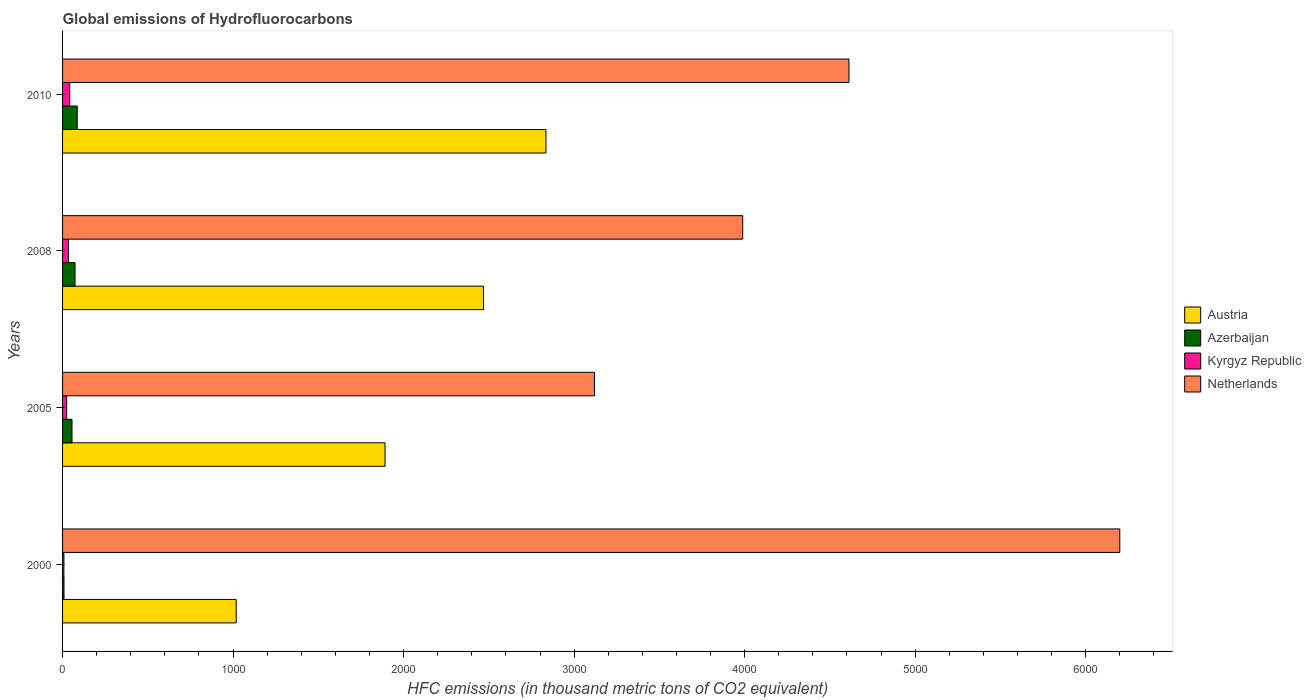How many groups of bars are there?
Your answer should be very brief. 4. Are the number of bars on each tick of the Y-axis equal?
Provide a short and direct response. Yes. How many bars are there on the 4th tick from the bottom?
Provide a succinct answer. 4. What is the global emissions of Hydrofluorocarbons in Austria in 2005?
Offer a very short reply. 1891.2. Across all years, what is the minimum global emissions of Hydrofluorocarbons in Azerbaijan?
Your answer should be very brief. 8.5. What is the total global emissions of Hydrofluorocarbons in Kyrgyz Republic in the graph?
Offer a terse response. 108.7. What is the difference between the global emissions of Hydrofluorocarbons in Austria in 2008 and that in 2010?
Ensure brevity in your answer.  -366.1. What is the difference between the global emissions of Hydrofluorocarbons in Kyrgyz Republic in 2010 and the global emissions of Hydrofluorocarbons in Netherlands in 2005?
Keep it short and to the point. -3077.5. What is the average global emissions of Hydrofluorocarbons in Austria per year?
Provide a short and direct response. 2053.38. In the year 2005, what is the difference between the global emissions of Hydrofluorocarbons in Netherlands and global emissions of Hydrofluorocarbons in Austria?
Give a very brief answer. 1228.3. What is the ratio of the global emissions of Hydrofluorocarbons in Kyrgyz Republic in 2000 to that in 2010?
Your answer should be compact. 0.19. Is the global emissions of Hydrofluorocarbons in Austria in 2000 less than that in 2010?
Provide a short and direct response. Yes. What is the difference between the highest and the second highest global emissions of Hydrofluorocarbons in Azerbaijan?
Offer a terse response. 12.9. What is the difference between the highest and the lowest global emissions of Hydrofluorocarbons in Austria?
Offer a terse response. 1816.6. Is the sum of the global emissions of Hydrofluorocarbons in Kyrgyz Republic in 2000 and 2005 greater than the maximum global emissions of Hydrofluorocarbons in Azerbaijan across all years?
Make the answer very short. No. What does the 2nd bar from the top in 2005 represents?
Your response must be concise. Kyrgyz Republic. What does the 2nd bar from the bottom in 2008 represents?
Your answer should be very brief. Azerbaijan. How many bars are there?
Your response must be concise. 16. Are all the bars in the graph horizontal?
Your answer should be compact. Yes. Are the values on the major ticks of X-axis written in scientific E-notation?
Your response must be concise. No. What is the title of the graph?
Your answer should be very brief. Global emissions of Hydrofluorocarbons. What is the label or title of the X-axis?
Provide a succinct answer. HFC emissions (in thousand metric tons of CO2 equivalent). What is the HFC emissions (in thousand metric tons of CO2 equivalent) of Austria in 2000?
Your answer should be compact. 1018.4. What is the HFC emissions (in thousand metric tons of CO2 equivalent) in Azerbaijan in 2000?
Offer a terse response. 8.5. What is the HFC emissions (in thousand metric tons of CO2 equivalent) of Netherlands in 2000?
Offer a terse response. 6200.4. What is the HFC emissions (in thousand metric tons of CO2 equivalent) in Austria in 2005?
Your response must be concise. 1891.2. What is the HFC emissions (in thousand metric tons of CO2 equivalent) in Azerbaijan in 2005?
Give a very brief answer. 55.4. What is the HFC emissions (in thousand metric tons of CO2 equivalent) of Netherlands in 2005?
Give a very brief answer. 3119.5. What is the HFC emissions (in thousand metric tons of CO2 equivalent) in Austria in 2008?
Offer a very short reply. 2468.9. What is the HFC emissions (in thousand metric tons of CO2 equivalent) of Azerbaijan in 2008?
Offer a terse response. 73.1. What is the HFC emissions (in thousand metric tons of CO2 equivalent) in Kyrgyz Republic in 2008?
Provide a short and direct response. 34.8. What is the HFC emissions (in thousand metric tons of CO2 equivalent) of Netherlands in 2008?
Give a very brief answer. 3988.8. What is the HFC emissions (in thousand metric tons of CO2 equivalent) in Austria in 2010?
Make the answer very short. 2835. What is the HFC emissions (in thousand metric tons of CO2 equivalent) in Kyrgyz Republic in 2010?
Offer a very short reply. 42. What is the HFC emissions (in thousand metric tons of CO2 equivalent) in Netherlands in 2010?
Keep it short and to the point. 4612. Across all years, what is the maximum HFC emissions (in thousand metric tons of CO2 equivalent) in Austria?
Offer a terse response. 2835. Across all years, what is the maximum HFC emissions (in thousand metric tons of CO2 equivalent) of Azerbaijan?
Give a very brief answer. 86. Across all years, what is the maximum HFC emissions (in thousand metric tons of CO2 equivalent) in Netherlands?
Give a very brief answer. 6200.4. Across all years, what is the minimum HFC emissions (in thousand metric tons of CO2 equivalent) in Austria?
Give a very brief answer. 1018.4. Across all years, what is the minimum HFC emissions (in thousand metric tons of CO2 equivalent) in Azerbaijan?
Give a very brief answer. 8.5. Across all years, what is the minimum HFC emissions (in thousand metric tons of CO2 equivalent) in Kyrgyz Republic?
Make the answer very short. 7.9. Across all years, what is the minimum HFC emissions (in thousand metric tons of CO2 equivalent) in Netherlands?
Offer a very short reply. 3119.5. What is the total HFC emissions (in thousand metric tons of CO2 equivalent) in Austria in the graph?
Provide a short and direct response. 8213.5. What is the total HFC emissions (in thousand metric tons of CO2 equivalent) in Azerbaijan in the graph?
Provide a succinct answer. 223. What is the total HFC emissions (in thousand metric tons of CO2 equivalent) in Kyrgyz Republic in the graph?
Offer a terse response. 108.7. What is the total HFC emissions (in thousand metric tons of CO2 equivalent) in Netherlands in the graph?
Your response must be concise. 1.79e+04. What is the difference between the HFC emissions (in thousand metric tons of CO2 equivalent) in Austria in 2000 and that in 2005?
Offer a very short reply. -872.8. What is the difference between the HFC emissions (in thousand metric tons of CO2 equivalent) of Azerbaijan in 2000 and that in 2005?
Offer a terse response. -46.9. What is the difference between the HFC emissions (in thousand metric tons of CO2 equivalent) of Kyrgyz Republic in 2000 and that in 2005?
Your answer should be very brief. -16.1. What is the difference between the HFC emissions (in thousand metric tons of CO2 equivalent) of Netherlands in 2000 and that in 2005?
Offer a terse response. 3080.9. What is the difference between the HFC emissions (in thousand metric tons of CO2 equivalent) in Austria in 2000 and that in 2008?
Provide a short and direct response. -1450.5. What is the difference between the HFC emissions (in thousand metric tons of CO2 equivalent) in Azerbaijan in 2000 and that in 2008?
Make the answer very short. -64.6. What is the difference between the HFC emissions (in thousand metric tons of CO2 equivalent) in Kyrgyz Republic in 2000 and that in 2008?
Make the answer very short. -26.9. What is the difference between the HFC emissions (in thousand metric tons of CO2 equivalent) in Netherlands in 2000 and that in 2008?
Offer a very short reply. 2211.6. What is the difference between the HFC emissions (in thousand metric tons of CO2 equivalent) of Austria in 2000 and that in 2010?
Your answer should be compact. -1816.6. What is the difference between the HFC emissions (in thousand metric tons of CO2 equivalent) of Azerbaijan in 2000 and that in 2010?
Provide a succinct answer. -77.5. What is the difference between the HFC emissions (in thousand metric tons of CO2 equivalent) of Kyrgyz Republic in 2000 and that in 2010?
Offer a very short reply. -34.1. What is the difference between the HFC emissions (in thousand metric tons of CO2 equivalent) of Netherlands in 2000 and that in 2010?
Your response must be concise. 1588.4. What is the difference between the HFC emissions (in thousand metric tons of CO2 equivalent) in Austria in 2005 and that in 2008?
Your response must be concise. -577.7. What is the difference between the HFC emissions (in thousand metric tons of CO2 equivalent) in Azerbaijan in 2005 and that in 2008?
Your answer should be compact. -17.7. What is the difference between the HFC emissions (in thousand metric tons of CO2 equivalent) in Netherlands in 2005 and that in 2008?
Provide a succinct answer. -869.3. What is the difference between the HFC emissions (in thousand metric tons of CO2 equivalent) in Austria in 2005 and that in 2010?
Offer a terse response. -943.8. What is the difference between the HFC emissions (in thousand metric tons of CO2 equivalent) in Azerbaijan in 2005 and that in 2010?
Your answer should be very brief. -30.6. What is the difference between the HFC emissions (in thousand metric tons of CO2 equivalent) of Kyrgyz Republic in 2005 and that in 2010?
Keep it short and to the point. -18. What is the difference between the HFC emissions (in thousand metric tons of CO2 equivalent) in Netherlands in 2005 and that in 2010?
Your answer should be compact. -1492.5. What is the difference between the HFC emissions (in thousand metric tons of CO2 equivalent) in Austria in 2008 and that in 2010?
Your response must be concise. -366.1. What is the difference between the HFC emissions (in thousand metric tons of CO2 equivalent) in Netherlands in 2008 and that in 2010?
Give a very brief answer. -623.2. What is the difference between the HFC emissions (in thousand metric tons of CO2 equivalent) in Austria in 2000 and the HFC emissions (in thousand metric tons of CO2 equivalent) in Azerbaijan in 2005?
Give a very brief answer. 963. What is the difference between the HFC emissions (in thousand metric tons of CO2 equivalent) in Austria in 2000 and the HFC emissions (in thousand metric tons of CO2 equivalent) in Kyrgyz Republic in 2005?
Provide a succinct answer. 994.4. What is the difference between the HFC emissions (in thousand metric tons of CO2 equivalent) in Austria in 2000 and the HFC emissions (in thousand metric tons of CO2 equivalent) in Netherlands in 2005?
Offer a terse response. -2101.1. What is the difference between the HFC emissions (in thousand metric tons of CO2 equivalent) of Azerbaijan in 2000 and the HFC emissions (in thousand metric tons of CO2 equivalent) of Kyrgyz Republic in 2005?
Provide a succinct answer. -15.5. What is the difference between the HFC emissions (in thousand metric tons of CO2 equivalent) of Azerbaijan in 2000 and the HFC emissions (in thousand metric tons of CO2 equivalent) of Netherlands in 2005?
Offer a very short reply. -3111. What is the difference between the HFC emissions (in thousand metric tons of CO2 equivalent) in Kyrgyz Republic in 2000 and the HFC emissions (in thousand metric tons of CO2 equivalent) in Netherlands in 2005?
Your answer should be compact. -3111.6. What is the difference between the HFC emissions (in thousand metric tons of CO2 equivalent) of Austria in 2000 and the HFC emissions (in thousand metric tons of CO2 equivalent) of Azerbaijan in 2008?
Offer a very short reply. 945.3. What is the difference between the HFC emissions (in thousand metric tons of CO2 equivalent) in Austria in 2000 and the HFC emissions (in thousand metric tons of CO2 equivalent) in Kyrgyz Republic in 2008?
Provide a succinct answer. 983.6. What is the difference between the HFC emissions (in thousand metric tons of CO2 equivalent) of Austria in 2000 and the HFC emissions (in thousand metric tons of CO2 equivalent) of Netherlands in 2008?
Your response must be concise. -2970.4. What is the difference between the HFC emissions (in thousand metric tons of CO2 equivalent) of Azerbaijan in 2000 and the HFC emissions (in thousand metric tons of CO2 equivalent) of Kyrgyz Republic in 2008?
Make the answer very short. -26.3. What is the difference between the HFC emissions (in thousand metric tons of CO2 equivalent) of Azerbaijan in 2000 and the HFC emissions (in thousand metric tons of CO2 equivalent) of Netherlands in 2008?
Provide a short and direct response. -3980.3. What is the difference between the HFC emissions (in thousand metric tons of CO2 equivalent) in Kyrgyz Republic in 2000 and the HFC emissions (in thousand metric tons of CO2 equivalent) in Netherlands in 2008?
Your answer should be compact. -3980.9. What is the difference between the HFC emissions (in thousand metric tons of CO2 equivalent) in Austria in 2000 and the HFC emissions (in thousand metric tons of CO2 equivalent) in Azerbaijan in 2010?
Provide a succinct answer. 932.4. What is the difference between the HFC emissions (in thousand metric tons of CO2 equivalent) in Austria in 2000 and the HFC emissions (in thousand metric tons of CO2 equivalent) in Kyrgyz Republic in 2010?
Your answer should be compact. 976.4. What is the difference between the HFC emissions (in thousand metric tons of CO2 equivalent) of Austria in 2000 and the HFC emissions (in thousand metric tons of CO2 equivalent) of Netherlands in 2010?
Ensure brevity in your answer.  -3593.6. What is the difference between the HFC emissions (in thousand metric tons of CO2 equivalent) of Azerbaijan in 2000 and the HFC emissions (in thousand metric tons of CO2 equivalent) of Kyrgyz Republic in 2010?
Your response must be concise. -33.5. What is the difference between the HFC emissions (in thousand metric tons of CO2 equivalent) of Azerbaijan in 2000 and the HFC emissions (in thousand metric tons of CO2 equivalent) of Netherlands in 2010?
Ensure brevity in your answer.  -4603.5. What is the difference between the HFC emissions (in thousand metric tons of CO2 equivalent) of Kyrgyz Republic in 2000 and the HFC emissions (in thousand metric tons of CO2 equivalent) of Netherlands in 2010?
Your response must be concise. -4604.1. What is the difference between the HFC emissions (in thousand metric tons of CO2 equivalent) of Austria in 2005 and the HFC emissions (in thousand metric tons of CO2 equivalent) of Azerbaijan in 2008?
Provide a succinct answer. 1818.1. What is the difference between the HFC emissions (in thousand metric tons of CO2 equivalent) in Austria in 2005 and the HFC emissions (in thousand metric tons of CO2 equivalent) in Kyrgyz Republic in 2008?
Give a very brief answer. 1856.4. What is the difference between the HFC emissions (in thousand metric tons of CO2 equivalent) of Austria in 2005 and the HFC emissions (in thousand metric tons of CO2 equivalent) of Netherlands in 2008?
Offer a terse response. -2097.6. What is the difference between the HFC emissions (in thousand metric tons of CO2 equivalent) in Azerbaijan in 2005 and the HFC emissions (in thousand metric tons of CO2 equivalent) in Kyrgyz Republic in 2008?
Your answer should be very brief. 20.6. What is the difference between the HFC emissions (in thousand metric tons of CO2 equivalent) in Azerbaijan in 2005 and the HFC emissions (in thousand metric tons of CO2 equivalent) in Netherlands in 2008?
Make the answer very short. -3933.4. What is the difference between the HFC emissions (in thousand metric tons of CO2 equivalent) in Kyrgyz Republic in 2005 and the HFC emissions (in thousand metric tons of CO2 equivalent) in Netherlands in 2008?
Keep it short and to the point. -3964.8. What is the difference between the HFC emissions (in thousand metric tons of CO2 equivalent) of Austria in 2005 and the HFC emissions (in thousand metric tons of CO2 equivalent) of Azerbaijan in 2010?
Your answer should be very brief. 1805.2. What is the difference between the HFC emissions (in thousand metric tons of CO2 equivalent) of Austria in 2005 and the HFC emissions (in thousand metric tons of CO2 equivalent) of Kyrgyz Republic in 2010?
Your response must be concise. 1849.2. What is the difference between the HFC emissions (in thousand metric tons of CO2 equivalent) of Austria in 2005 and the HFC emissions (in thousand metric tons of CO2 equivalent) of Netherlands in 2010?
Your answer should be very brief. -2720.8. What is the difference between the HFC emissions (in thousand metric tons of CO2 equivalent) of Azerbaijan in 2005 and the HFC emissions (in thousand metric tons of CO2 equivalent) of Netherlands in 2010?
Your answer should be very brief. -4556.6. What is the difference between the HFC emissions (in thousand metric tons of CO2 equivalent) of Kyrgyz Republic in 2005 and the HFC emissions (in thousand metric tons of CO2 equivalent) of Netherlands in 2010?
Provide a short and direct response. -4588. What is the difference between the HFC emissions (in thousand metric tons of CO2 equivalent) in Austria in 2008 and the HFC emissions (in thousand metric tons of CO2 equivalent) in Azerbaijan in 2010?
Your response must be concise. 2382.9. What is the difference between the HFC emissions (in thousand metric tons of CO2 equivalent) of Austria in 2008 and the HFC emissions (in thousand metric tons of CO2 equivalent) of Kyrgyz Republic in 2010?
Provide a succinct answer. 2426.9. What is the difference between the HFC emissions (in thousand metric tons of CO2 equivalent) in Austria in 2008 and the HFC emissions (in thousand metric tons of CO2 equivalent) in Netherlands in 2010?
Keep it short and to the point. -2143.1. What is the difference between the HFC emissions (in thousand metric tons of CO2 equivalent) of Azerbaijan in 2008 and the HFC emissions (in thousand metric tons of CO2 equivalent) of Kyrgyz Republic in 2010?
Provide a short and direct response. 31.1. What is the difference between the HFC emissions (in thousand metric tons of CO2 equivalent) in Azerbaijan in 2008 and the HFC emissions (in thousand metric tons of CO2 equivalent) in Netherlands in 2010?
Offer a terse response. -4538.9. What is the difference between the HFC emissions (in thousand metric tons of CO2 equivalent) in Kyrgyz Republic in 2008 and the HFC emissions (in thousand metric tons of CO2 equivalent) in Netherlands in 2010?
Offer a very short reply. -4577.2. What is the average HFC emissions (in thousand metric tons of CO2 equivalent) in Austria per year?
Keep it short and to the point. 2053.38. What is the average HFC emissions (in thousand metric tons of CO2 equivalent) of Azerbaijan per year?
Your answer should be compact. 55.75. What is the average HFC emissions (in thousand metric tons of CO2 equivalent) of Kyrgyz Republic per year?
Offer a very short reply. 27.18. What is the average HFC emissions (in thousand metric tons of CO2 equivalent) in Netherlands per year?
Offer a terse response. 4480.18. In the year 2000, what is the difference between the HFC emissions (in thousand metric tons of CO2 equivalent) in Austria and HFC emissions (in thousand metric tons of CO2 equivalent) in Azerbaijan?
Your answer should be very brief. 1009.9. In the year 2000, what is the difference between the HFC emissions (in thousand metric tons of CO2 equivalent) of Austria and HFC emissions (in thousand metric tons of CO2 equivalent) of Kyrgyz Republic?
Provide a short and direct response. 1010.5. In the year 2000, what is the difference between the HFC emissions (in thousand metric tons of CO2 equivalent) in Austria and HFC emissions (in thousand metric tons of CO2 equivalent) in Netherlands?
Keep it short and to the point. -5182. In the year 2000, what is the difference between the HFC emissions (in thousand metric tons of CO2 equivalent) in Azerbaijan and HFC emissions (in thousand metric tons of CO2 equivalent) in Kyrgyz Republic?
Give a very brief answer. 0.6. In the year 2000, what is the difference between the HFC emissions (in thousand metric tons of CO2 equivalent) in Azerbaijan and HFC emissions (in thousand metric tons of CO2 equivalent) in Netherlands?
Make the answer very short. -6191.9. In the year 2000, what is the difference between the HFC emissions (in thousand metric tons of CO2 equivalent) of Kyrgyz Republic and HFC emissions (in thousand metric tons of CO2 equivalent) of Netherlands?
Ensure brevity in your answer.  -6192.5. In the year 2005, what is the difference between the HFC emissions (in thousand metric tons of CO2 equivalent) in Austria and HFC emissions (in thousand metric tons of CO2 equivalent) in Azerbaijan?
Provide a succinct answer. 1835.8. In the year 2005, what is the difference between the HFC emissions (in thousand metric tons of CO2 equivalent) of Austria and HFC emissions (in thousand metric tons of CO2 equivalent) of Kyrgyz Republic?
Offer a terse response. 1867.2. In the year 2005, what is the difference between the HFC emissions (in thousand metric tons of CO2 equivalent) in Austria and HFC emissions (in thousand metric tons of CO2 equivalent) in Netherlands?
Ensure brevity in your answer.  -1228.3. In the year 2005, what is the difference between the HFC emissions (in thousand metric tons of CO2 equivalent) in Azerbaijan and HFC emissions (in thousand metric tons of CO2 equivalent) in Kyrgyz Republic?
Your response must be concise. 31.4. In the year 2005, what is the difference between the HFC emissions (in thousand metric tons of CO2 equivalent) in Azerbaijan and HFC emissions (in thousand metric tons of CO2 equivalent) in Netherlands?
Offer a very short reply. -3064.1. In the year 2005, what is the difference between the HFC emissions (in thousand metric tons of CO2 equivalent) in Kyrgyz Republic and HFC emissions (in thousand metric tons of CO2 equivalent) in Netherlands?
Provide a short and direct response. -3095.5. In the year 2008, what is the difference between the HFC emissions (in thousand metric tons of CO2 equivalent) of Austria and HFC emissions (in thousand metric tons of CO2 equivalent) of Azerbaijan?
Your answer should be compact. 2395.8. In the year 2008, what is the difference between the HFC emissions (in thousand metric tons of CO2 equivalent) of Austria and HFC emissions (in thousand metric tons of CO2 equivalent) of Kyrgyz Republic?
Provide a succinct answer. 2434.1. In the year 2008, what is the difference between the HFC emissions (in thousand metric tons of CO2 equivalent) in Austria and HFC emissions (in thousand metric tons of CO2 equivalent) in Netherlands?
Your answer should be compact. -1519.9. In the year 2008, what is the difference between the HFC emissions (in thousand metric tons of CO2 equivalent) of Azerbaijan and HFC emissions (in thousand metric tons of CO2 equivalent) of Kyrgyz Republic?
Ensure brevity in your answer.  38.3. In the year 2008, what is the difference between the HFC emissions (in thousand metric tons of CO2 equivalent) of Azerbaijan and HFC emissions (in thousand metric tons of CO2 equivalent) of Netherlands?
Your answer should be very brief. -3915.7. In the year 2008, what is the difference between the HFC emissions (in thousand metric tons of CO2 equivalent) in Kyrgyz Republic and HFC emissions (in thousand metric tons of CO2 equivalent) in Netherlands?
Your response must be concise. -3954. In the year 2010, what is the difference between the HFC emissions (in thousand metric tons of CO2 equivalent) in Austria and HFC emissions (in thousand metric tons of CO2 equivalent) in Azerbaijan?
Keep it short and to the point. 2749. In the year 2010, what is the difference between the HFC emissions (in thousand metric tons of CO2 equivalent) of Austria and HFC emissions (in thousand metric tons of CO2 equivalent) of Kyrgyz Republic?
Keep it short and to the point. 2793. In the year 2010, what is the difference between the HFC emissions (in thousand metric tons of CO2 equivalent) of Austria and HFC emissions (in thousand metric tons of CO2 equivalent) of Netherlands?
Provide a short and direct response. -1777. In the year 2010, what is the difference between the HFC emissions (in thousand metric tons of CO2 equivalent) in Azerbaijan and HFC emissions (in thousand metric tons of CO2 equivalent) in Kyrgyz Republic?
Keep it short and to the point. 44. In the year 2010, what is the difference between the HFC emissions (in thousand metric tons of CO2 equivalent) of Azerbaijan and HFC emissions (in thousand metric tons of CO2 equivalent) of Netherlands?
Provide a succinct answer. -4526. In the year 2010, what is the difference between the HFC emissions (in thousand metric tons of CO2 equivalent) of Kyrgyz Republic and HFC emissions (in thousand metric tons of CO2 equivalent) of Netherlands?
Your answer should be compact. -4570. What is the ratio of the HFC emissions (in thousand metric tons of CO2 equivalent) in Austria in 2000 to that in 2005?
Keep it short and to the point. 0.54. What is the ratio of the HFC emissions (in thousand metric tons of CO2 equivalent) in Azerbaijan in 2000 to that in 2005?
Your answer should be very brief. 0.15. What is the ratio of the HFC emissions (in thousand metric tons of CO2 equivalent) in Kyrgyz Republic in 2000 to that in 2005?
Keep it short and to the point. 0.33. What is the ratio of the HFC emissions (in thousand metric tons of CO2 equivalent) of Netherlands in 2000 to that in 2005?
Keep it short and to the point. 1.99. What is the ratio of the HFC emissions (in thousand metric tons of CO2 equivalent) of Austria in 2000 to that in 2008?
Your answer should be very brief. 0.41. What is the ratio of the HFC emissions (in thousand metric tons of CO2 equivalent) of Azerbaijan in 2000 to that in 2008?
Provide a succinct answer. 0.12. What is the ratio of the HFC emissions (in thousand metric tons of CO2 equivalent) in Kyrgyz Republic in 2000 to that in 2008?
Ensure brevity in your answer.  0.23. What is the ratio of the HFC emissions (in thousand metric tons of CO2 equivalent) of Netherlands in 2000 to that in 2008?
Your answer should be very brief. 1.55. What is the ratio of the HFC emissions (in thousand metric tons of CO2 equivalent) in Austria in 2000 to that in 2010?
Your response must be concise. 0.36. What is the ratio of the HFC emissions (in thousand metric tons of CO2 equivalent) in Azerbaijan in 2000 to that in 2010?
Give a very brief answer. 0.1. What is the ratio of the HFC emissions (in thousand metric tons of CO2 equivalent) in Kyrgyz Republic in 2000 to that in 2010?
Make the answer very short. 0.19. What is the ratio of the HFC emissions (in thousand metric tons of CO2 equivalent) in Netherlands in 2000 to that in 2010?
Your answer should be compact. 1.34. What is the ratio of the HFC emissions (in thousand metric tons of CO2 equivalent) in Austria in 2005 to that in 2008?
Your answer should be compact. 0.77. What is the ratio of the HFC emissions (in thousand metric tons of CO2 equivalent) in Azerbaijan in 2005 to that in 2008?
Offer a very short reply. 0.76. What is the ratio of the HFC emissions (in thousand metric tons of CO2 equivalent) in Kyrgyz Republic in 2005 to that in 2008?
Your answer should be compact. 0.69. What is the ratio of the HFC emissions (in thousand metric tons of CO2 equivalent) in Netherlands in 2005 to that in 2008?
Offer a very short reply. 0.78. What is the ratio of the HFC emissions (in thousand metric tons of CO2 equivalent) of Austria in 2005 to that in 2010?
Make the answer very short. 0.67. What is the ratio of the HFC emissions (in thousand metric tons of CO2 equivalent) of Azerbaijan in 2005 to that in 2010?
Your answer should be compact. 0.64. What is the ratio of the HFC emissions (in thousand metric tons of CO2 equivalent) in Netherlands in 2005 to that in 2010?
Provide a short and direct response. 0.68. What is the ratio of the HFC emissions (in thousand metric tons of CO2 equivalent) of Austria in 2008 to that in 2010?
Offer a very short reply. 0.87. What is the ratio of the HFC emissions (in thousand metric tons of CO2 equivalent) in Kyrgyz Republic in 2008 to that in 2010?
Offer a terse response. 0.83. What is the ratio of the HFC emissions (in thousand metric tons of CO2 equivalent) in Netherlands in 2008 to that in 2010?
Your response must be concise. 0.86. What is the difference between the highest and the second highest HFC emissions (in thousand metric tons of CO2 equivalent) of Austria?
Make the answer very short. 366.1. What is the difference between the highest and the second highest HFC emissions (in thousand metric tons of CO2 equivalent) in Kyrgyz Republic?
Offer a terse response. 7.2. What is the difference between the highest and the second highest HFC emissions (in thousand metric tons of CO2 equivalent) in Netherlands?
Your response must be concise. 1588.4. What is the difference between the highest and the lowest HFC emissions (in thousand metric tons of CO2 equivalent) of Austria?
Ensure brevity in your answer.  1816.6. What is the difference between the highest and the lowest HFC emissions (in thousand metric tons of CO2 equivalent) in Azerbaijan?
Your response must be concise. 77.5. What is the difference between the highest and the lowest HFC emissions (in thousand metric tons of CO2 equivalent) of Kyrgyz Republic?
Your response must be concise. 34.1. What is the difference between the highest and the lowest HFC emissions (in thousand metric tons of CO2 equivalent) in Netherlands?
Your answer should be compact. 3080.9. 